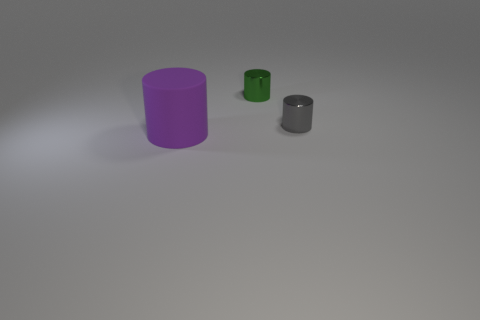Subtract 1 cylinders. How many cylinders are left? 2 Add 1 gray objects. How many objects exist? 4 Subtract all metallic cylinders. Subtract all gray metal balls. How many objects are left? 1 Add 2 purple matte things. How many purple matte things are left? 3 Add 2 cylinders. How many cylinders exist? 5 Subtract 0 brown cylinders. How many objects are left? 3 